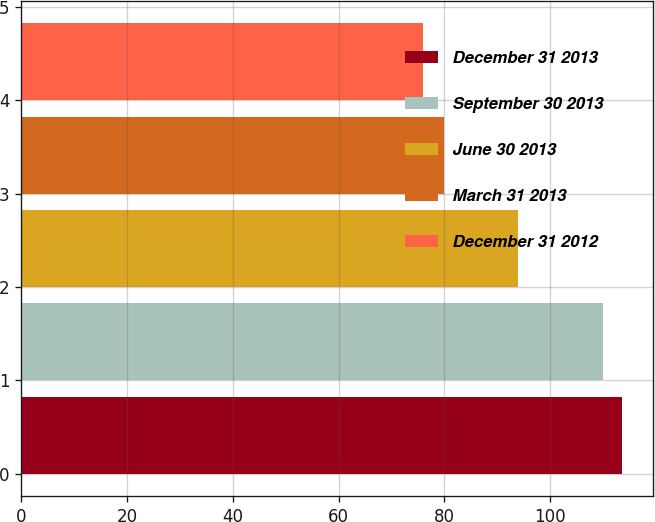Convert chart to OTSL. <chart><loc_0><loc_0><loc_500><loc_500><bar_chart><fcel>December 31 2013<fcel>September 30 2013<fcel>June 30 2013<fcel>March 31 2013<fcel>December 31 2012<nl><fcel>113.7<fcel>110<fcel>94<fcel>80<fcel>76<nl></chart> 